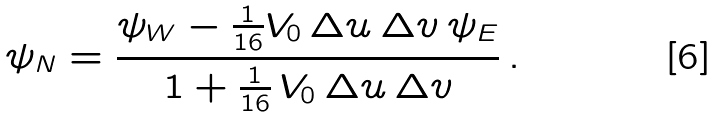Convert formula to latex. <formula><loc_0><loc_0><loc_500><loc_500>\psi _ { N } = \frac { \psi _ { W } - \frac { 1 } { 1 6 } V _ { 0 } \, \Delta u \, \Delta v \, \psi _ { E } } { 1 + \frac { 1 } { 1 6 } \, V _ { 0 } \, \Delta u \, \Delta v } \, .</formula> 